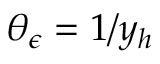Convert formula to latex. <formula><loc_0><loc_0><loc_500><loc_500>\theta _ { \epsilon } = 1 / y _ { h }</formula> 